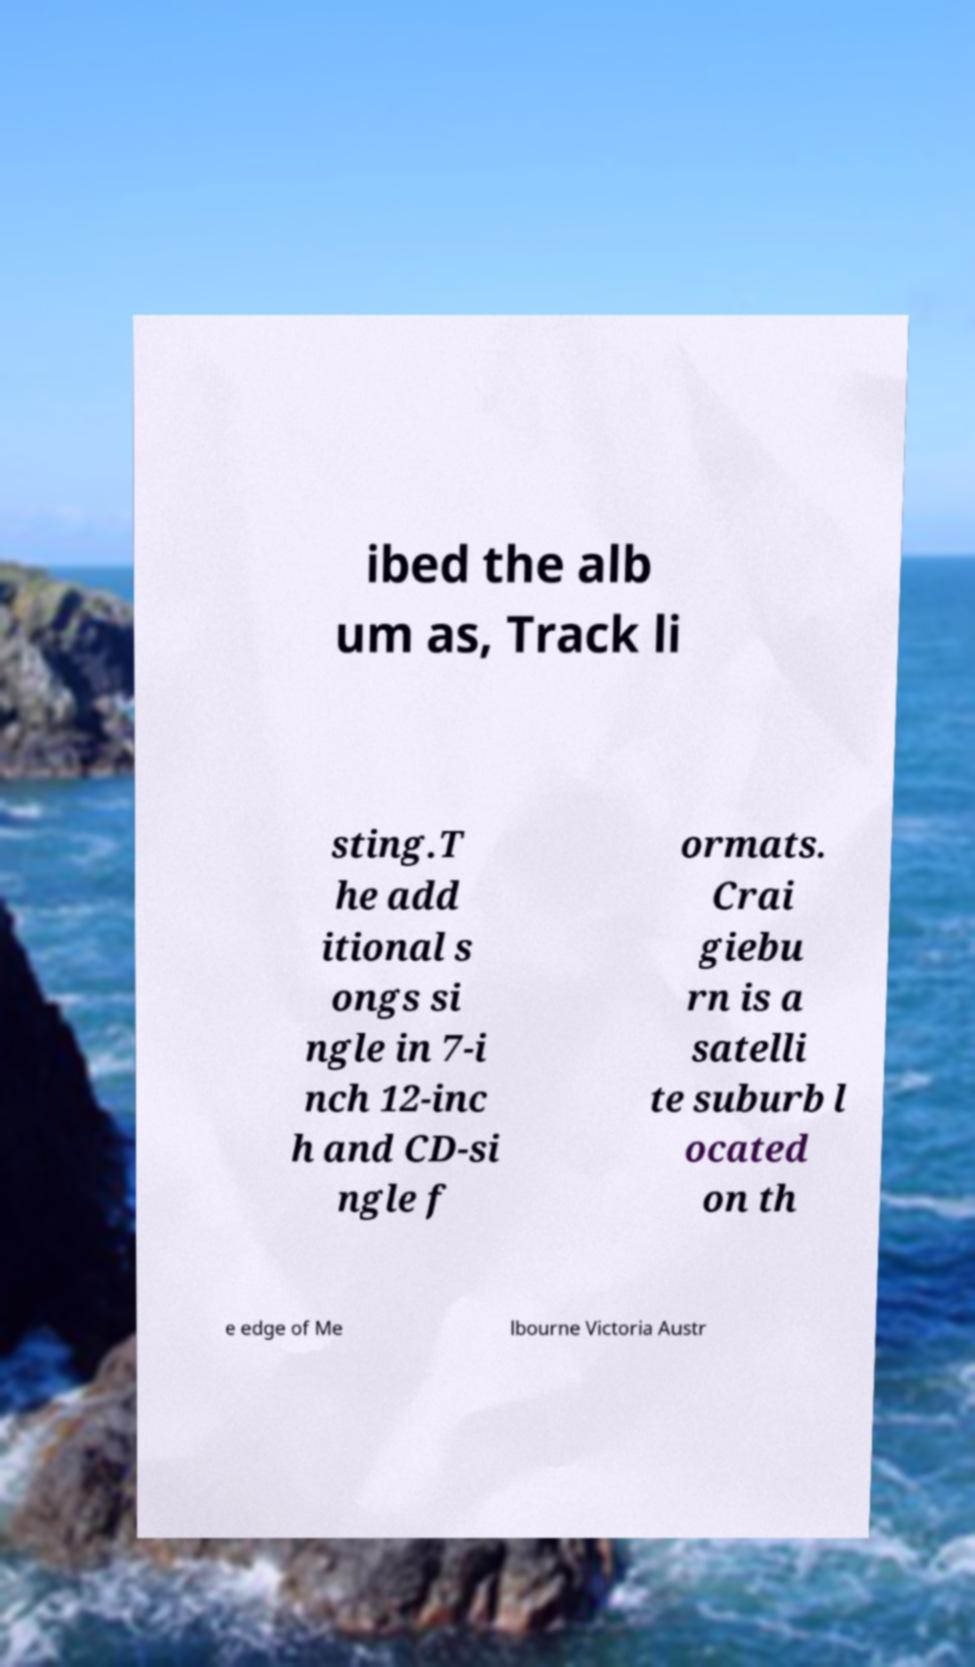For documentation purposes, I need the text within this image transcribed. Could you provide that? ibed the alb um as, Track li sting.T he add itional s ongs si ngle in 7-i nch 12-inc h and CD-si ngle f ormats. Crai giebu rn is a satelli te suburb l ocated on th e edge of Me lbourne Victoria Austr 